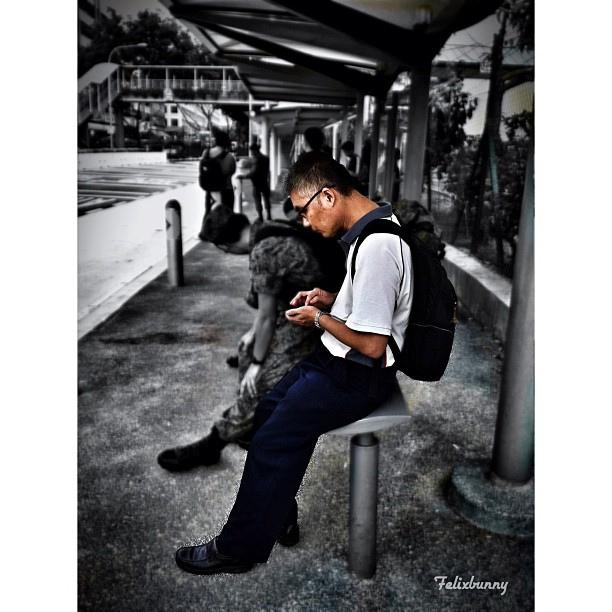Where is the man storing his things? Please explain your reasoning. backpack. The man is wearing a bag in the back. 